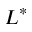Convert formula to latex. <formula><loc_0><loc_0><loc_500><loc_500>L ^ { * }</formula> 